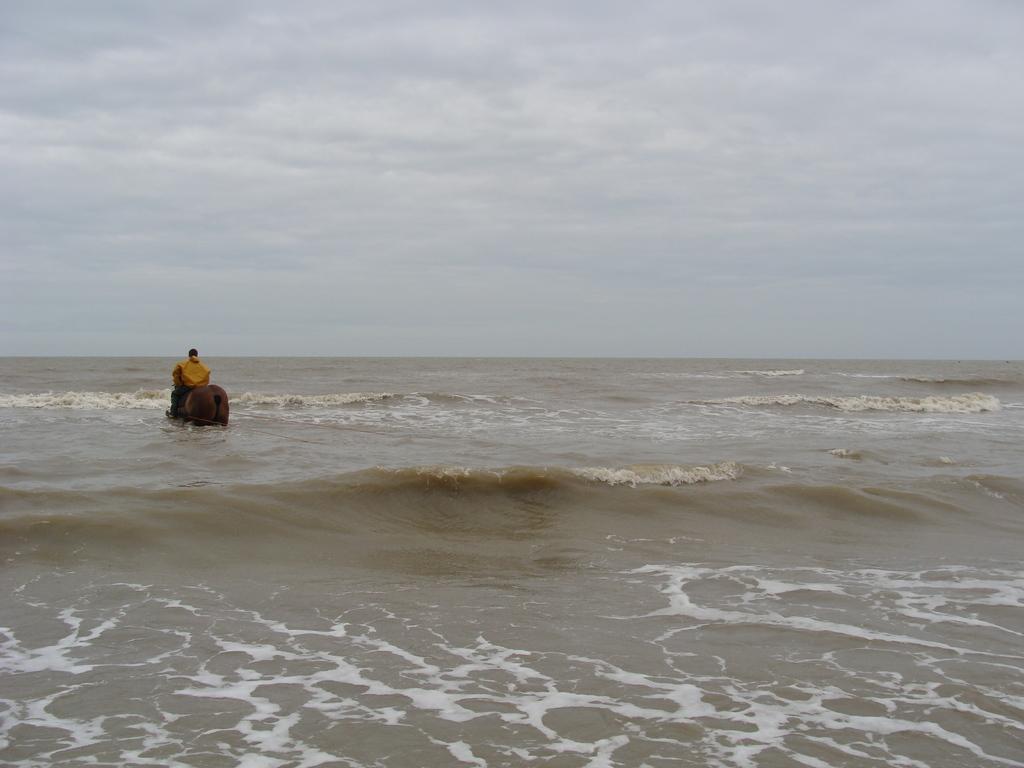Please provide a concise description of this image. This is the picture of a beach in which there is a person on the animal. 